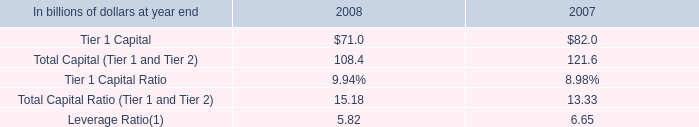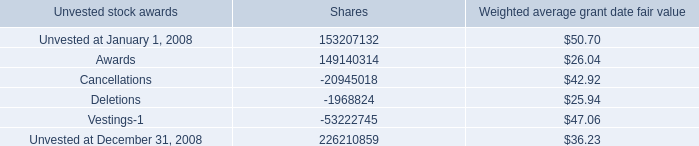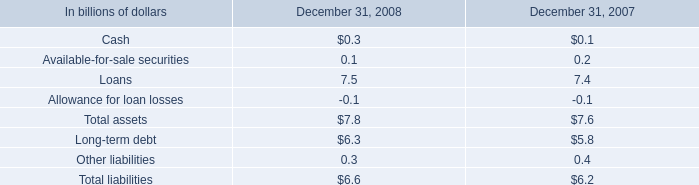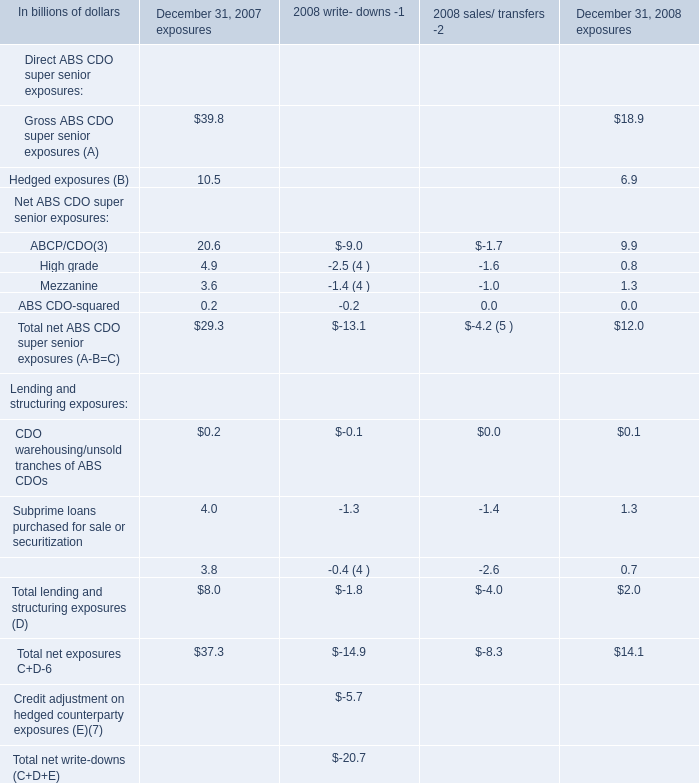what was the approximate value of the shares that vested during 2008 
Computations: (53222745 * 22.31)
Answer: 1187399440.95. 